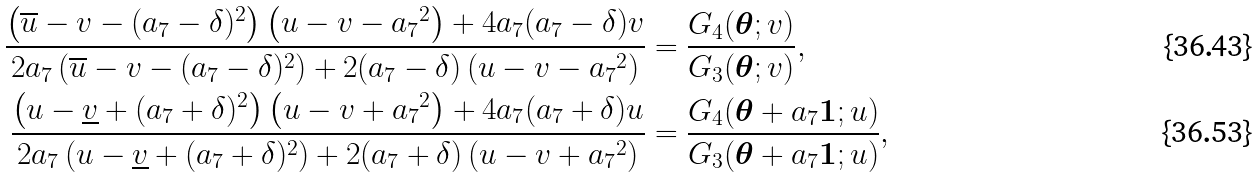Convert formula to latex. <formula><loc_0><loc_0><loc_500><loc_500>\frac { \left ( \overline { u } - v - ( a _ { 7 } - \delta ) ^ { 2 } \right ) \left ( u - v - { a _ { 7 } } ^ { 2 } \right ) + 4 a _ { 7 } ( a _ { 7 } - \delta ) v } { 2 a _ { 7 } \left ( \overline { u } - v - ( a _ { 7 } - \delta ) ^ { 2 } \right ) + 2 ( a _ { 7 } - \delta ) \left ( u - v - { a _ { 7 } } ^ { 2 } \right ) } & = \frac { G _ { 4 } ( { \boldsymbol \theta } ; v ) } { G _ { 3 } ( { \boldsymbol \theta } ; v ) } , \\ \frac { \left ( u - \underline { v } + ( a _ { 7 } + \delta ) ^ { 2 } \right ) \left ( u - v + { a _ { 7 } } ^ { 2 } \right ) + 4 a _ { 7 } ( a _ { 7 } + \delta ) u } { 2 a _ { 7 } \left ( u - \underline { v } + ( a _ { 7 } + \delta ) ^ { 2 } \right ) + 2 ( a _ { 7 } + \delta ) \left ( u - v + { a _ { 7 } } ^ { 2 } \right ) } & = \frac { G _ { 4 } ( { \boldsymbol \theta } + a _ { 7 } { \boldsymbol 1 } ; u ) } { G _ { 3 } ( { \boldsymbol \theta } + a _ { 7 } { \boldsymbol 1 } ; u ) } ,</formula> 